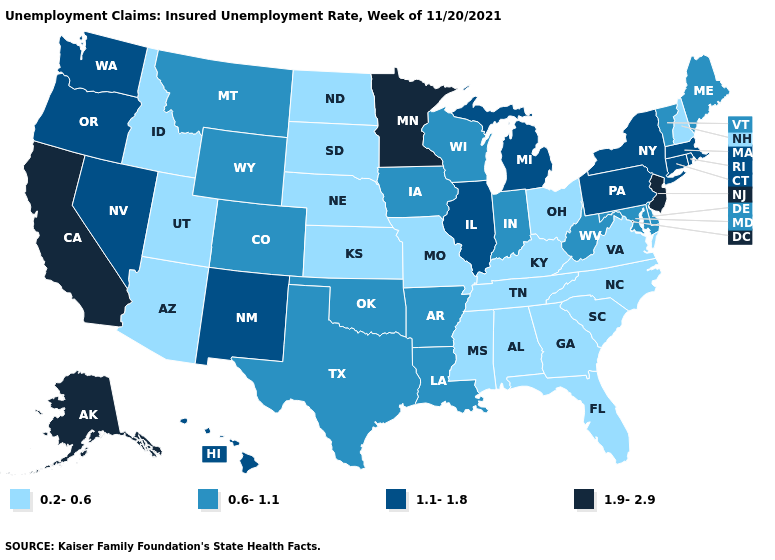Name the states that have a value in the range 1.1-1.8?
Short answer required. Connecticut, Hawaii, Illinois, Massachusetts, Michigan, Nevada, New Mexico, New York, Oregon, Pennsylvania, Rhode Island, Washington. Among the states that border Alabama , which have the highest value?
Concise answer only. Florida, Georgia, Mississippi, Tennessee. Does Iowa have a lower value than Vermont?
Quick response, please. No. Does the first symbol in the legend represent the smallest category?
Concise answer only. Yes. Which states have the lowest value in the USA?
Be succinct. Alabama, Arizona, Florida, Georgia, Idaho, Kansas, Kentucky, Mississippi, Missouri, Nebraska, New Hampshire, North Carolina, North Dakota, Ohio, South Carolina, South Dakota, Tennessee, Utah, Virginia. Which states have the lowest value in the Northeast?
Quick response, please. New Hampshire. Name the states that have a value in the range 0.2-0.6?
Give a very brief answer. Alabama, Arizona, Florida, Georgia, Idaho, Kansas, Kentucky, Mississippi, Missouri, Nebraska, New Hampshire, North Carolina, North Dakota, Ohio, South Carolina, South Dakota, Tennessee, Utah, Virginia. Name the states that have a value in the range 0.6-1.1?
Be succinct. Arkansas, Colorado, Delaware, Indiana, Iowa, Louisiana, Maine, Maryland, Montana, Oklahoma, Texas, Vermont, West Virginia, Wisconsin, Wyoming. Does the first symbol in the legend represent the smallest category?
Answer briefly. Yes. What is the value of Hawaii?
Write a very short answer. 1.1-1.8. What is the lowest value in states that border New Jersey?
Write a very short answer. 0.6-1.1. Which states have the highest value in the USA?
Be succinct. Alaska, California, Minnesota, New Jersey. What is the value of New Hampshire?
Be succinct. 0.2-0.6. 